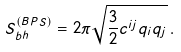Convert formula to latex. <formula><loc_0><loc_0><loc_500><loc_500>S _ { b h } ^ { ( B P S ) } = 2 \pi \sqrt { \frac { 3 } { 2 } c ^ { i j } q _ { i } q _ { j } } \, .</formula> 